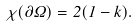<formula> <loc_0><loc_0><loc_500><loc_500>\chi ( \partial \Omega ) = 2 ( 1 - k ) .</formula> 